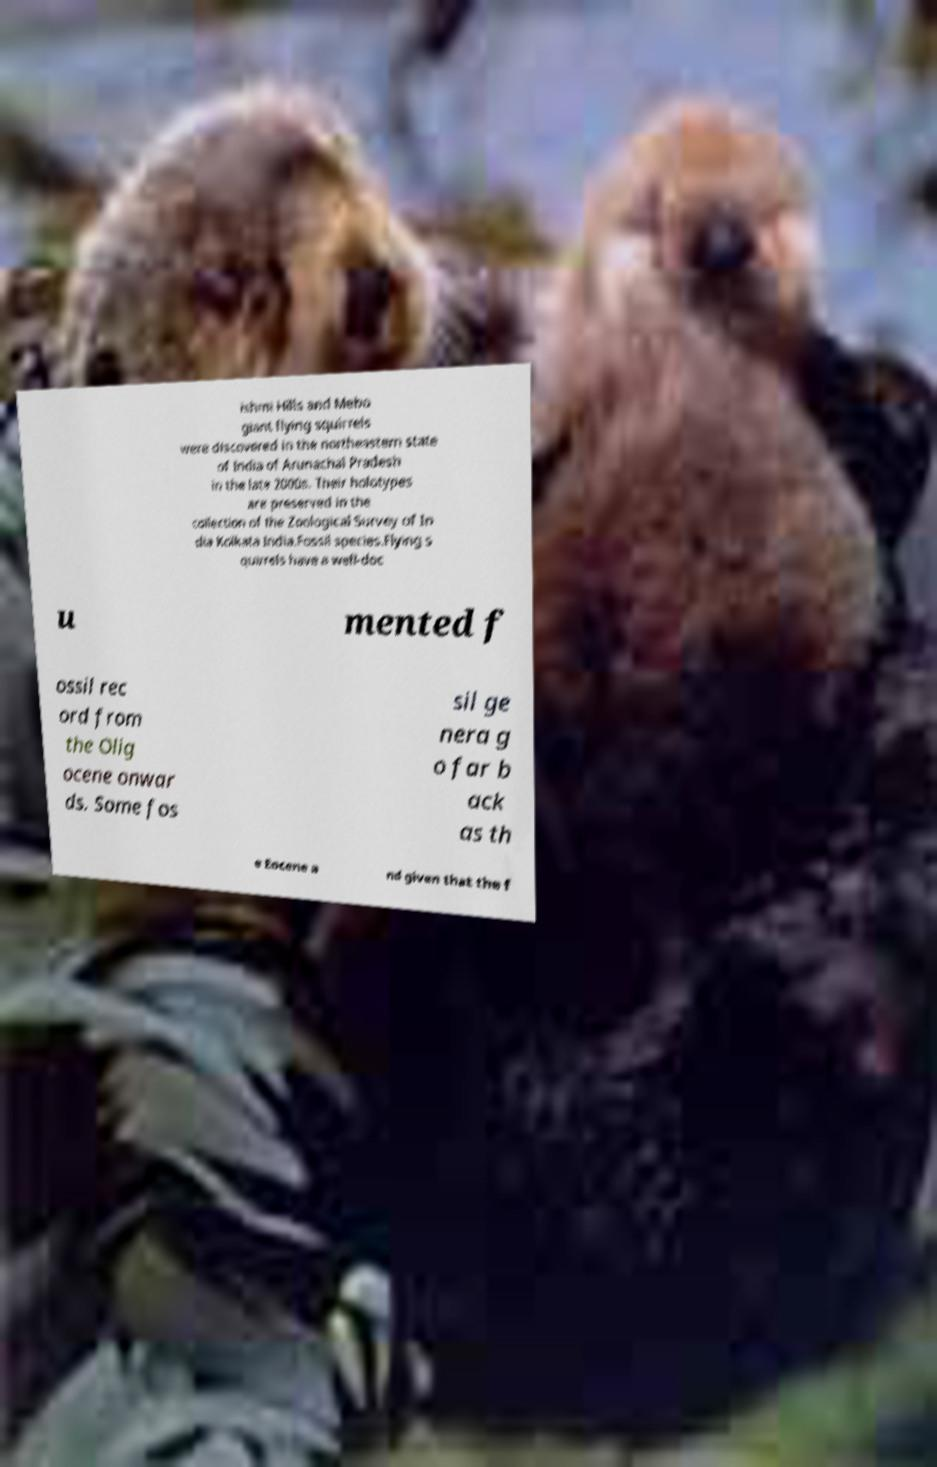There's text embedded in this image that I need extracted. Can you transcribe it verbatim? ishmi Hills and Mebo giant flying squirrels were discovered in the northeastern state of India of Arunachal Pradesh in the late 2000s. Their holotypes are preserved in the collection of the Zoological Survey of In dia Kolkata India.Fossil species.Flying s quirrels have a well-doc u mented f ossil rec ord from the Olig ocene onwar ds. Some fos sil ge nera g o far b ack as th e Eocene a nd given that the f 